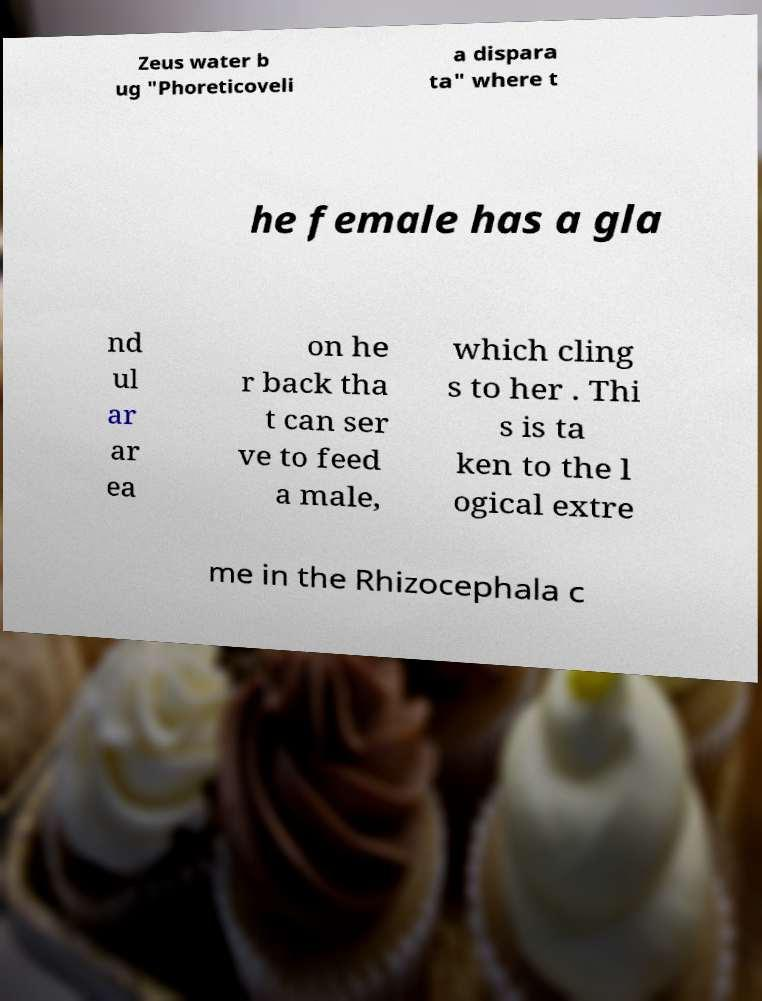Can you accurately transcribe the text from the provided image for me? Zeus water b ug "Phoreticoveli a dispara ta" where t he female has a gla nd ul ar ar ea on he r back tha t can ser ve to feed a male, which cling s to her . Thi s is ta ken to the l ogical extre me in the Rhizocephala c 